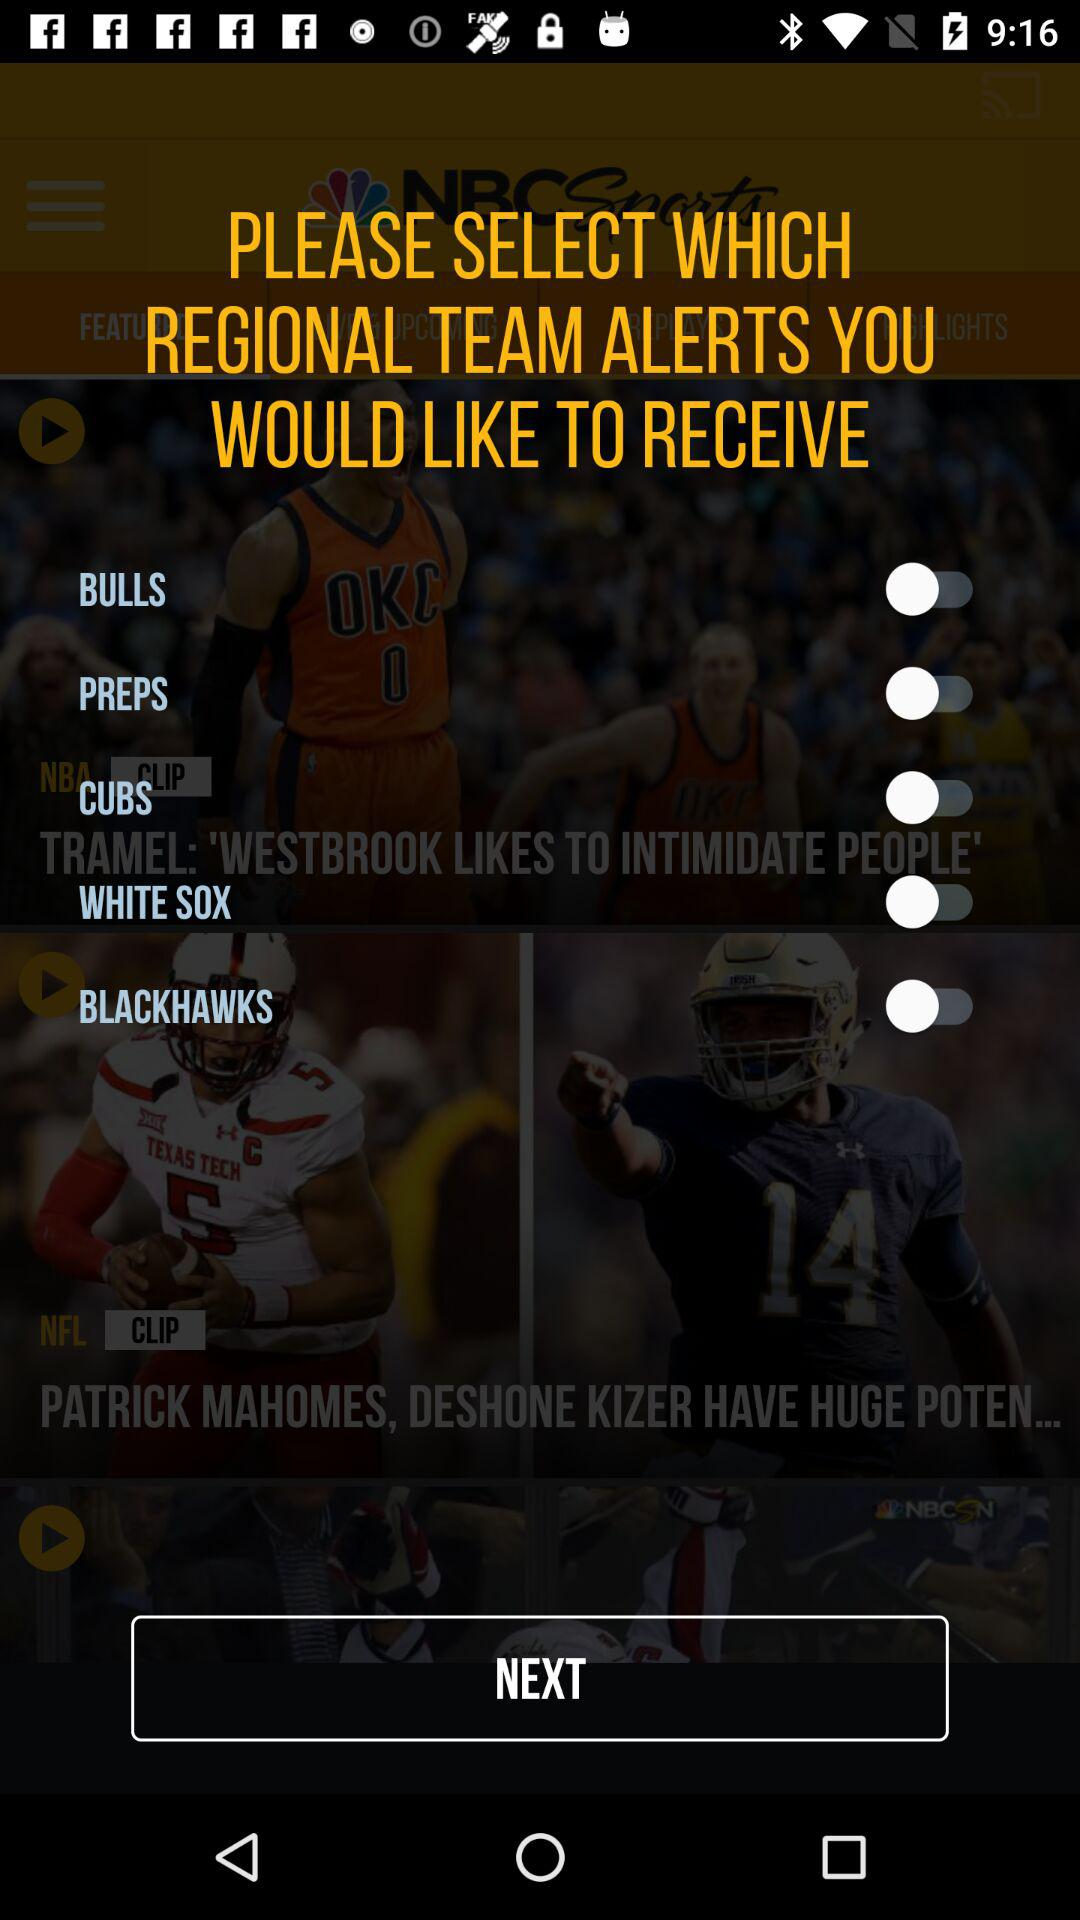What is the status of "PREPS"? The status of "PREPS" is "off". 